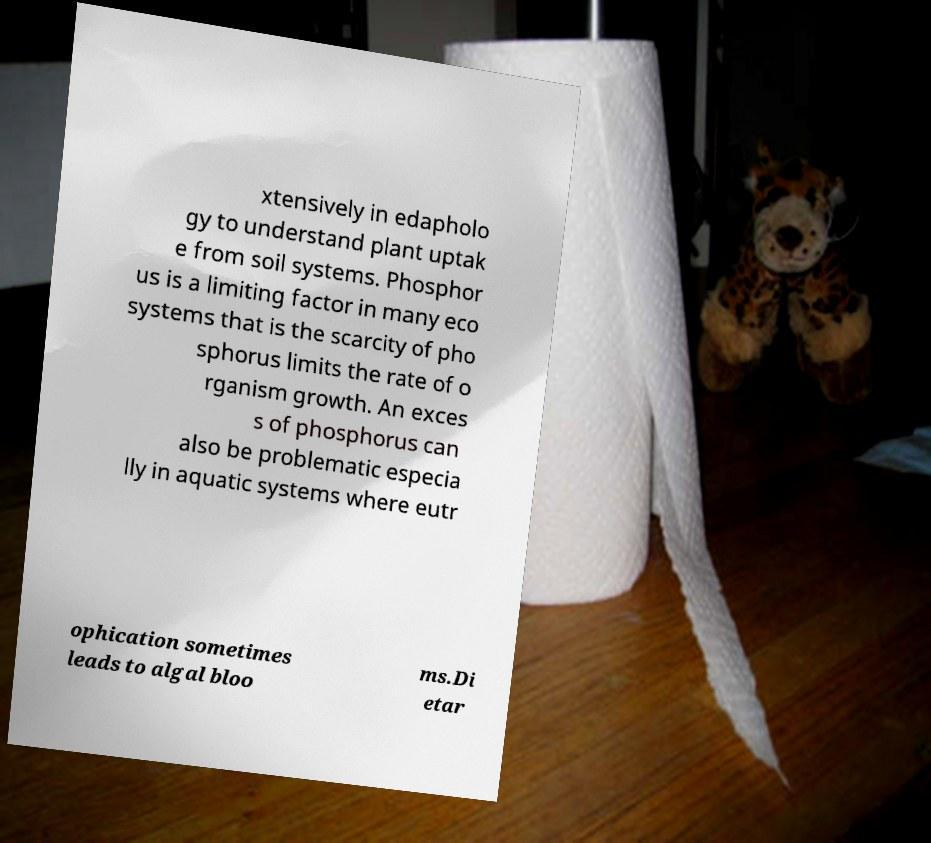There's text embedded in this image that I need extracted. Can you transcribe it verbatim? xtensively in edapholo gy to understand plant uptak e from soil systems. Phosphor us is a limiting factor in many eco systems that is the scarcity of pho sphorus limits the rate of o rganism growth. An exces s of phosphorus can also be problematic especia lly in aquatic systems where eutr ophication sometimes leads to algal bloo ms.Di etar 